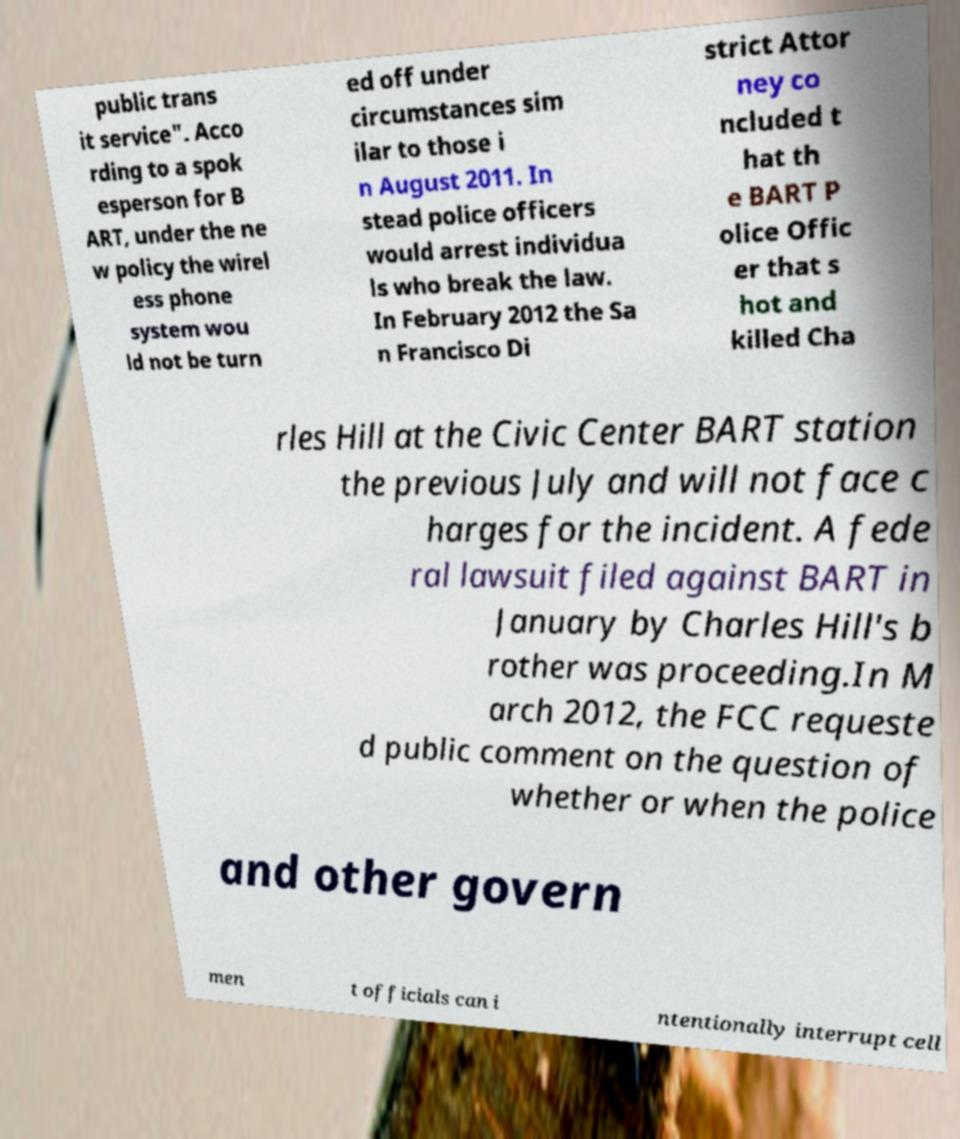Can you accurately transcribe the text from the provided image for me? public trans it service". Acco rding to a spok esperson for B ART, under the ne w policy the wirel ess phone system wou ld not be turn ed off under circumstances sim ilar to those i n August 2011. In stead police officers would arrest individua ls who break the law. In February 2012 the Sa n Francisco Di strict Attor ney co ncluded t hat th e BART P olice Offic er that s hot and killed Cha rles Hill at the Civic Center BART station the previous July and will not face c harges for the incident. A fede ral lawsuit filed against BART in January by Charles Hill's b rother was proceeding.In M arch 2012, the FCC requeste d public comment on the question of whether or when the police and other govern men t officials can i ntentionally interrupt cell 